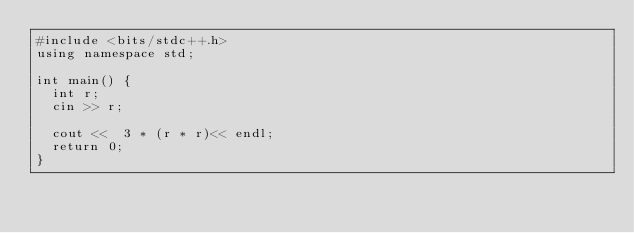Convert code to text. <code><loc_0><loc_0><loc_500><loc_500><_C++_>#include <bits/stdc++.h>
using namespace std;

int main() {
  int r;
  cin >> r;

  cout <<  3 * (r * r)<< endl;
  return 0;
}
</code> 